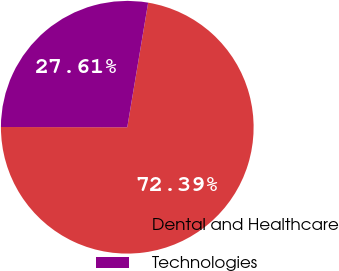Convert chart to OTSL. <chart><loc_0><loc_0><loc_500><loc_500><pie_chart><fcel>Dental and Healthcare<fcel>Technologies<nl><fcel>72.39%<fcel>27.61%<nl></chart> 